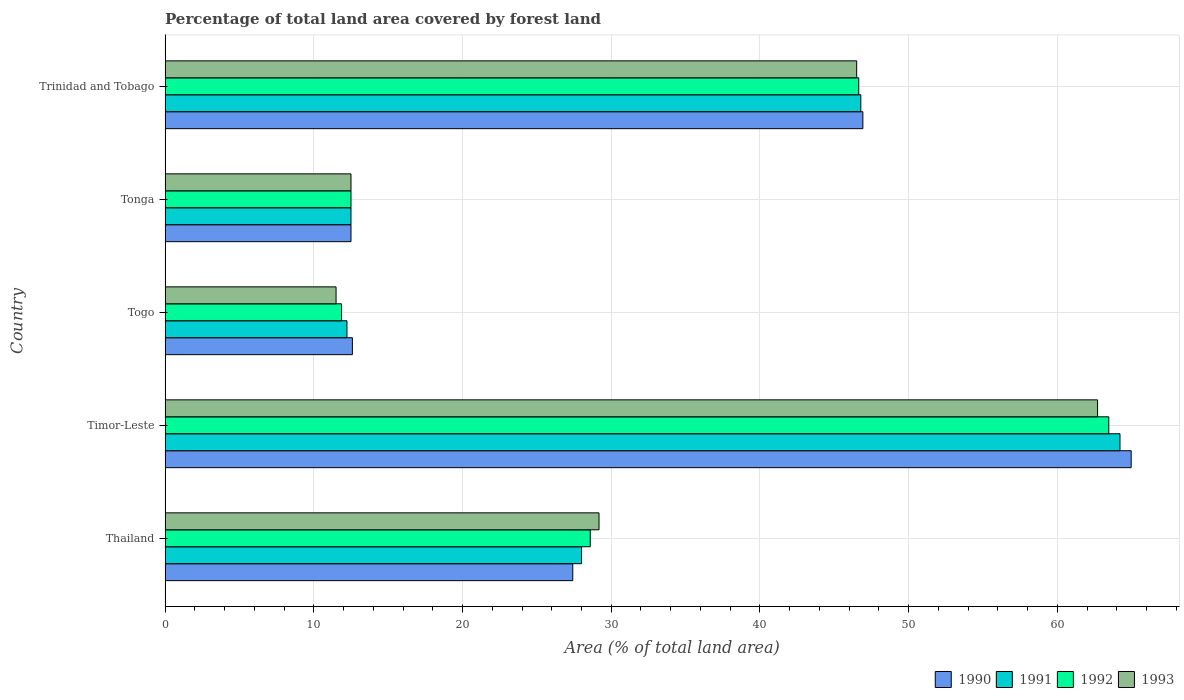How many groups of bars are there?
Your answer should be very brief. 5. Are the number of bars per tick equal to the number of legend labels?
Give a very brief answer. Yes. Are the number of bars on each tick of the Y-axis equal?
Your answer should be compact. Yes. How many bars are there on the 3rd tick from the top?
Provide a succinct answer. 4. What is the label of the 1st group of bars from the top?
Your answer should be very brief. Trinidad and Tobago. In how many cases, is the number of bars for a given country not equal to the number of legend labels?
Your answer should be very brief. 0. Across all countries, what is the maximum percentage of forest land in 1992?
Make the answer very short. 63.46. Across all countries, what is the minimum percentage of forest land in 1992?
Keep it short and to the point. 11.86. In which country was the percentage of forest land in 1992 maximum?
Your answer should be very brief. Timor-Leste. In which country was the percentage of forest land in 1990 minimum?
Make the answer very short. Tonga. What is the total percentage of forest land in 1991 in the graph?
Your answer should be very brief. 163.72. What is the difference between the percentage of forest land in 1990 in Tonga and that in Trinidad and Tobago?
Your answer should be very brief. -34.42. What is the difference between the percentage of forest land in 1990 in Togo and the percentage of forest land in 1991 in Timor-Leste?
Your response must be concise. -51.62. What is the average percentage of forest land in 1991 per country?
Offer a terse response. 32.74. What is the difference between the percentage of forest land in 1993 and percentage of forest land in 1990 in Thailand?
Offer a terse response. 1.77. In how many countries, is the percentage of forest land in 1990 greater than 60 %?
Ensure brevity in your answer.  1. What is the ratio of the percentage of forest land in 1990 in Timor-Leste to that in Trinidad and Tobago?
Offer a very short reply. 1.38. Is the difference between the percentage of forest land in 1993 in Tonga and Trinidad and Tobago greater than the difference between the percentage of forest land in 1990 in Tonga and Trinidad and Tobago?
Your answer should be compact. Yes. What is the difference between the highest and the second highest percentage of forest land in 1992?
Your answer should be compact. 16.81. What is the difference between the highest and the lowest percentage of forest land in 1991?
Provide a short and direct response. 51.98. Is the sum of the percentage of forest land in 1992 in Togo and Trinidad and Tobago greater than the maximum percentage of forest land in 1991 across all countries?
Give a very brief answer. No. Is it the case that in every country, the sum of the percentage of forest land in 1990 and percentage of forest land in 1992 is greater than the sum of percentage of forest land in 1991 and percentage of forest land in 1993?
Offer a terse response. No. What does the 1st bar from the top in Timor-Leste represents?
Your answer should be compact. 1993. How many bars are there?
Your answer should be very brief. 20. Are all the bars in the graph horizontal?
Offer a very short reply. Yes. How many countries are there in the graph?
Your response must be concise. 5. What is the difference between two consecutive major ticks on the X-axis?
Provide a succinct answer. 10. Are the values on the major ticks of X-axis written in scientific E-notation?
Offer a terse response. No. Does the graph contain grids?
Provide a succinct answer. Yes. Where does the legend appear in the graph?
Offer a terse response. Bottom right. What is the title of the graph?
Offer a very short reply. Percentage of total land area covered by forest land. Does "1989" appear as one of the legend labels in the graph?
Your response must be concise. No. What is the label or title of the X-axis?
Provide a succinct answer. Area (% of total land area). What is the Area (% of total land area) of 1990 in Thailand?
Ensure brevity in your answer.  27.41. What is the Area (% of total land area) of 1991 in Thailand?
Make the answer very short. 28. What is the Area (% of total land area) of 1992 in Thailand?
Your response must be concise. 28.59. What is the Area (% of total land area) in 1993 in Thailand?
Offer a terse response. 29.18. What is the Area (% of total land area) of 1990 in Timor-Leste?
Provide a succinct answer. 64.96. What is the Area (% of total land area) of 1991 in Timor-Leste?
Offer a terse response. 64.21. What is the Area (% of total land area) of 1992 in Timor-Leste?
Offer a terse response. 63.46. What is the Area (% of total land area) of 1993 in Timor-Leste?
Provide a short and direct response. 62.7. What is the Area (% of total land area) in 1990 in Togo?
Ensure brevity in your answer.  12.59. What is the Area (% of total land area) in 1991 in Togo?
Offer a very short reply. 12.23. What is the Area (% of total land area) in 1992 in Togo?
Provide a short and direct response. 11.86. What is the Area (% of total land area) of 1993 in Togo?
Offer a very short reply. 11.5. What is the Area (% of total land area) of 1992 in Tonga?
Offer a very short reply. 12.5. What is the Area (% of total land area) of 1993 in Tonga?
Ensure brevity in your answer.  12.5. What is the Area (% of total land area) of 1990 in Trinidad and Tobago?
Make the answer very short. 46.92. What is the Area (% of total land area) in 1991 in Trinidad and Tobago?
Keep it short and to the point. 46.78. What is the Area (% of total land area) of 1992 in Trinidad and Tobago?
Offer a very short reply. 46.64. What is the Area (% of total land area) in 1993 in Trinidad and Tobago?
Provide a short and direct response. 46.5. Across all countries, what is the maximum Area (% of total land area) in 1990?
Your answer should be very brief. 64.96. Across all countries, what is the maximum Area (% of total land area) of 1991?
Give a very brief answer. 64.21. Across all countries, what is the maximum Area (% of total land area) of 1992?
Offer a terse response. 63.46. Across all countries, what is the maximum Area (% of total land area) of 1993?
Your response must be concise. 62.7. Across all countries, what is the minimum Area (% of total land area) of 1991?
Your answer should be very brief. 12.23. Across all countries, what is the minimum Area (% of total land area) in 1992?
Make the answer very short. 11.86. Across all countries, what is the minimum Area (% of total land area) in 1993?
Offer a very short reply. 11.5. What is the total Area (% of total land area) in 1990 in the graph?
Offer a terse response. 164.39. What is the total Area (% of total land area) in 1991 in the graph?
Your answer should be compact. 163.72. What is the total Area (% of total land area) in 1992 in the graph?
Your answer should be very brief. 163.05. What is the total Area (% of total land area) of 1993 in the graph?
Provide a short and direct response. 162.38. What is the difference between the Area (% of total land area) in 1990 in Thailand and that in Timor-Leste?
Your answer should be compact. -37.55. What is the difference between the Area (% of total land area) in 1991 in Thailand and that in Timor-Leste?
Your response must be concise. -36.21. What is the difference between the Area (% of total land area) in 1992 in Thailand and that in Timor-Leste?
Keep it short and to the point. -34.87. What is the difference between the Area (% of total land area) in 1993 in Thailand and that in Timor-Leste?
Offer a terse response. -33.53. What is the difference between the Area (% of total land area) in 1990 in Thailand and that in Togo?
Offer a terse response. 14.82. What is the difference between the Area (% of total land area) in 1991 in Thailand and that in Togo?
Offer a terse response. 15.77. What is the difference between the Area (% of total land area) in 1992 in Thailand and that in Togo?
Make the answer very short. 16.73. What is the difference between the Area (% of total land area) of 1993 in Thailand and that in Togo?
Offer a very short reply. 17.68. What is the difference between the Area (% of total land area) of 1990 in Thailand and that in Tonga?
Keep it short and to the point. 14.91. What is the difference between the Area (% of total land area) of 1991 in Thailand and that in Tonga?
Ensure brevity in your answer.  15.5. What is the difference between the Area (% of total land area) of 1992 in Thailand and that in Tonga?
Give a very brief answer. 16.09. What is the difference between the Area (% of total land area) in 1993 in Thailand and that in Tonga?
Offer a terse response. 16.68. What is the difference between the Area (% of total land area) in 1990 in Thailand and that in Trinidad and Tobago?
Offer a very short reply. -19.51. What is the difference between the Area (% of total land area) of 1991 in Thailand and that in Trinidad and Tobago?
Provide a short and direct response. -18.78. What is the difference between the Area (% of total land area) of 1992 in Thailand and that in Trinidad and Tobago?
Your answer should be compact. -18.05. What is the difference between the Area (% of total land area) of 1993 in Thailand and that in Trinidad and Tobago?
Ensure brevity in your answer.  -17.33. What is the difference between the Area (% of total land area) in 1990 in Timor-Leste and that in Togo?
Offer a terse response. 52.37. What is the difference between the Area (% of total land area) of 1991 in Timor-Leste and that in Togo?
Give a very brief answer. 51.98. What is the difference between the Area (% of total land area) of 1992 in Timor-Leste and that in Togo?
Provide a short and direct response. 51.59. What is the difference between the Area (% of total land area) of 1993 in Timor-Leste and that in Togo?
Provide a short and direct response. 51.21. What is the difference between the Area (% of total land area) in 1990 in Timor-Leste and that in Tonga?
Your response must be concise. 52.46. What is the difference between the Area (% of total land area) of 1991 in Timor-Leste and that in Tonga?
Your answer should be very brief. 51.71. What is the difference between the Area (% of total land area) in 1992 in Timor-Leste and that in Tonga?
Offer a terse response. 50.96. What is the difference between the Area (% of total land area) in 1993 in Timor-Leste and that in Tonga?
Give a very brief answer. 50.2. What is the difference between the Area (% of total land area) in 1990 in Timor-Leste and that in Trinidad and Tobago?
Your answer should be compact. 18.04. What is the difference between the Area (% of total land area) of 1991 in Timor-Leste and that in Trinidad and Tobago?
Make the answer very short. 17.43. What is the difference between the Area (% of total land area) in 1992 in Timor-Leste and that in Trinidad and Tobago?
Give a very brief answer. 16.81. What is the difference between the Area (% of total land area) of 1993 in Timor-Leste and that in Trinidad and Tobago?
Provide a succinct answer. 16.2. What is the difference between the Area (% of total land area) of 1990 in Togo and that in Tonga?
Keep it short and to the point. 0.09. What is the difference between the Area (% of total land area) in 1991 in Togo and that in Tonga?
Your answer should be very brief. -0.27. What is the difference between the Area (% of total land area) in 1992 in Togo and that in Tonga?
Your answer should be very brief. -0.64. What is the difference between the Area (% of total land area) in 1993 in Togo and that in Tonga?
Ensure brevity in your answer.  -1. What is the difference between the Area (% of total land area) in 1990 in Togo and that in Trinidad and Tobago?
Your answer should be very brief. -34.33. What is the difference between the Area (% of total land area) in 1991 in Togo and that in Trinidad and Tobago?
Offer a terse response. -34.55. What is the difference between the Area (% of total land area) in 1992 in Togo and that in Trinidad and Tobago?
Keep it short and to the point. -34.78. What is the difference between the Area (% of total land area) in 1993 in Togo and that in Trinidad and Tobago?
Your response must be concise. -35.01. What is the difference between the Area (% of total land area) of 1990 in Tonga and that in Trinidad and Tobago?
Provide a short and direct response. -34.42. What is the difference between the Area (% of total land area) of 1991 in Tonga and that in Trinidad and Tobago?
Offer a very short reply. -34.28. What is the difference between the Area (% of total land area) in 1992 in Tonga and that in Trinidad and Tobago?
Your answer should be compact. -34.14. What is the difference between the Area (% of total land area) of 1993 in Tonga and that in Trinidad and Tobago?
Your answer should be very brief. -34. What is the difference between the Area (% of total land area) in 1990 in Thailand and the Area (% of total land area) in 1991 in Timor-Leste?
Keep it short and to the point. -36.8. What is the difference between the Area (% of total land area) of 1990 in Thailand and the Area (% of total land area) of 1992 in Timor-Leste?
Offer a very short reply. -36.04. What is the difference between the Area (% of total land area) of 1990 in Thailand and the Area (% of total land area) of 1993 in Timor-Leste?
Give a very brief answer. -35.29. What is the difference between the Area (% of total land area) of 1991 in Thailand and the Area (% of total land area) of 1992 in Timor-Leste?
Offer a terse response. -35.46. What is the difference between the Area (% of total land area) in 1991 in Thailand and the Area (% of total land area) in 1993 in Timor-Leste?
Your answer should be compact. -34.7. What is the difference between the Area (% of total land area) of 1992 in Thailand and the Area (% of total land area) of 1993 in Timor-Leste?
Your response must be concise. -34.11. What is the difference between the Area (% of total land area) of 1990 in Thailand and the Area (% of total land area) of 1991 in Togo?
Your answer should be very brief. 15.18. What is the difference between the Area (% of total land area) of 1990 in Thailand and the Area (% of total land area) of 1992 in Togo?
Offer a very short reply. 15.55. What is the difference between the Area (% of total land area) in 1990 in Thailand and the Area (% of total land area) in 1993 in Togo?
Make the answer very short. 15.92. What is the difference between the Area (% of total land area) in 1991 in Thailand and the Area (% of total land area) in 1992 in Togo?
Offer a very short reply. 16.14. What is the difference between the Area (% of total land area) of 1991 in Thailand and the Area (% of total land area) of 1993 in Togo?
Offer a terse response. 16.5. What is the difference between the Area (% of total land area) of 1992 in Thailand and the Area (% of total land area) of 1993 in Togo?
Make the answer very short. 17.09. What is the difference between the Area (% of total land area) of 1990 in Thailand and the Area (% of total land area) of 1991 in Tonga?
Ensure brevity in your answer.  14.91. What is the difference between the Area (% of total land area) of 1990 in Thailand and the Area (% of total land area) of 1992 in Tonga?
Provide a succinct answer. 14.91. What is the difference between the Area (% of total land area) in 1990 in Thailand and the Area (% of total land area) in 1993 in Tonga?
Offer a very short reply. 14.91. What is the difference between the Area (% of total land area) of 1991 in Thailand and the Area (% of total land area) of 1992 in Tonga?
Ensure brevity in your answer.  15.5. What is the difference between the Area (% of total land area) in 1991 in Thailand and the Area (% of total land area) in 1993 in Tonga?
Provide a short and direct response. 15.5. What is the difference between the Area (% of total land area) in 1992 in Thailand and the Area (% of total land area) in 1993 in Tonga?
Keep it short and to the point. 16.09. What is the difference between the Area (% of total land area) in 1990 in Thailand and the Area (% of total land area) in 1991 in Trinidad and Tobago?
Make the answer very short. -19.37. What is the difference between the Area (% of total land area) in 1990 in Thailand and the Area (% of total land area) in 1992 in Trinidad and Tobago?
Make the answer very short. -19.23. What is the difference between the Area (% of total land area) in 1990 in Thailand and the Area (% of total land area) in 1993 in Trinidad and Tobago?
Offer a terse response. -19.09. What is the difference between the Area (% of total land area) of 1991 in Thailand and the Area (% of total land area) of 1992 in Trinidad and Tobago?
Your answer should be compact. -18.64. What is the difference between the Area (% of total land area) of 1991 in Thailand and the Area (% of total land area) of 1993 in Trinidad and Tobago?
Your answer should be very brief. -18.5. What is the difference between the Area (% of total land area) in 1992 in Thailand and the Area (% of total land area) in 1993 in Trinidad and Tobago?
Your answer should be very brief. -17.92. What is the difference between the Area (% of total land area) in 1990 in Timor-Leste and the Area (% of total land area) in 1991 in Togo?
Your response must be concise. 52.73. What is the difference between the Area (% of total land area) in 1990 in Timor-Leste and the Area (% of total land area) in 1992 in Togo?
Offer a terse response. 53.1. What is the difference between the Area (% of total land area) of 1990 in Timor-Leste and the Area (% of total land area) of 1993 in Togo?
Your answer should be very brief. 53.47. What is the difference between the Area (% of total land area) of 1991 in Timor-Leste and the Area (% of total land area) of 1992 in Togo?
Keep it short and to the point. 52.35. What is the difference between the Area (% of total land area) in 1991 in Timor-Leste and the Area (% of total land area) in 1993 in Togo?
Your answer should be compact. 52.71. What is the difference between the Area (% of total land area) in 1992 in Timor-Leste and the Area (% of total land area) in 1993 in Togo?
Your response must be concise. 51.96. What is the difference between the Area (% of total land area) of 1990 in Timor-Leste and the Area (% of total land area) of 1991 in Tonga?
Offer a very short reply. 52.46. What is the difference between the Area (% of total land area) in 1990 in Timor-Leste and the Area (% of total land area) in 1992 in Tonga?
Give a very brief answer. 52.46. What is the difference between the Area (% of total land area) in 1990 in Timor-Leste and the Area (% of total land area) in 1993 in Tonga?
Provide a succinct answer. 52.46. What is the difference between the Area (% of total land area) of 1991 in Timor-Leste and the Area (% of total land area) of 1992 in Tonga?
Your answer should be very brief. 51.71. What is the difference between the Area (% of total land area) in 1991 in Timor-Leste and the Area (% of total land area) in 1993 in Tonga?
Your answer should be compact. 51.71. What is the difference between the Area (% of total land area) in 1992 in Timor-Leste and the Area (% of total land area) in 1993 in Tonga?
Ensure brevity in your answer.  50.96. What is the difference between the Area (% of total land area) of 1990 in Timor-Leste and the Area (% of total land area) of 1991 in Trinidad and Tobago?
Provide a short and direct response. 18.18. What is the difference between the Area (% of total land area) of 1990 in Timor-Leste and the Area (% of total land area) of 1992 in Trinidad and Tobago?
Give a very brief answer. 18.32. What is the difference between the Area (% of total land area) in 1990 in Timor-Leste and the Area (% of total land area) in 1993 in Trinidad and Tobago?
Your answer should be compact. 18.46. What is the difference between the Area (% of total land area) in 1991 in Timor-Leste and the Area (% of total land area) in 1992 in Trinidad and Tobago?
Give a very brief answer. 17.57. What is the difference between the Area (% of total land area) in 1991 in Timor-Leste and the Area (% of total land area) in 1993 in Trinidad and Tobago?
Provide a short and direct response. 17.7. What is the difference between the Area (% of total land area) in 1992 in Timor-Leste and the Area (% of total land area) in 1993 in Trinidad and Tobago?
Provide a succinct answer. 16.95. What is the difference between the Area (% of total land area) in 1990 in Togo and the Area (% of total land area) in 1991 in Tonga?
Offer a very short reply. 0.09. What is the difference between the Area (% of total land area) of 1990 in Togo and the Area (% of total land area) of 1992 in Tonga?
Provide a succinct answer. 0.09. What is the difference between the Area (% of total land area) in 1990 in Togo and the Area (% of total land area) in 1993 in Tonga?
Offer a terse response. 0.09. What is the difference between the Area (% of total land area) of 1991 in Togo and the Area (% of total land area) of 1992 in Tonga?
Offer a terse response. -0.27. What is the difference between the Area (% of total land area) of 1991 in Togo and the Area (% of total land area) of 1993 in Tonga?
Keep it short and to the point. -0.27. What is the difference between the Area (% of total land area) of 1992 in Togo and the Area (% of total land area) of 1993 in Tonga?
Offer a very short reply. -0.64. What is the difference between the Area (% of total land area) of 1990 in Togo and the Area (% of total land area) of 1991 in Trinidad and Tobago?
Provide a succinct answer. -34.19. What is the difference between the Area (% of total land area) in 1990 in Togo and the Area (% of total land area) in 1992 in Trinidad and Tobago?
Give a very brief answer. -34.05. What is the difference between the Area (% of total land area) in 1990 in Togo and the Area (% of total land area) in 1993 in Trinidad and Tobago?
Provide a short and direct response. -33.91. What is the difference between the Area (% of total land area) of 1991 in Togo and the Area (% of total land area) of 1992 in Trinidad and Tobago?
Provide a succinct answer. -34.41. What is the difference between the Area (% of total land area) in 1991 in Togo and the Area (% of total land area) in 1993 in Trinidad and Tobago?
Provide a succinct answer. -34.28. What is the difference between the Area (% of total land area) of 1992 in Togo and the Area (% of total land area) of 1993 in Trinidad and Tobago?
Offer a very short reply. -34.64. What is the difference between the Area (% of total land area) in 1990 in Tonga and the Area (% of total land area) in 1991 in Trinidad and Tobago?
Offer a very short reply. -34.28. What is the difference between the Area (% of total land area) of 1990 in Tonga and the Area (% of total land area) of 1992 in Trinidad and Tobago?
Provide a succinct answer. -34.14. What is the difference between the Area (% of total land area) in 1990 in Tonga and the Area (% of total land area) in 1993 in Trinidad and Tobago?
Offer a terse response. -34. What is the difference between the Area (% of total land area) of 1991 in Tonga and the Area (% of total land area) of 1992 in Trinidad and Tobago?
Keep it short and to the point. -34.14. What is the difference between the Area (% of total land area) of 1991 in Tonga and the Area (% of total land area) of 1993 in Trinidad and Tobago?
Offer a very short reply. -34. What is the difference between the Area (% of total land area) in 1992 in Tonga and the Area (% of total land area) in 1993 in Trinidad and Tobago?
Keep it short and to the point. -34. What is the average Area (% of total land area) in 1990 per country?
Offer a terse response. 32.88. What is the average Area (% of total land area) of 1991 per country?
Make the answer very short. 32.74. What is the average Area (% of total land area) in 1992 per country?
Offer a terse response. 32.61. What is the average Area (% of total land area) in 1993 per country?
Your response must be concise. 32.48. What is the difference between the Area (% of total land area) of 1990 and Area (% of total land area) of 1991 in Thailand?
Provide a short and direct response. -0.59. What is the difference between the Area (% of total land area) in 1990 and Area (% of total land area) in 1992 in Thailand?
Provide a succinct answer. -1.18. What is the difference between the Area (% of total land area) of 1990 and Area (% of total land area) of 1993 in Thailand?
Offer a very short reply. -1.77. What is the difference between the Area (% of total land area) of 1991 and Area (% of total land area) of 1992 in Thailand?
Ensure brevity in your answer.  -0.59. What is the difference between the Area (% of total land area) in 1991 and Area (% of total land area) in 1993 in Thailand?
Give a very brief answer. -1.18. What is the difference between the Area (% of total land area) in 1992 and Area (% of total land area) in 1993 in Thailand?
Provide a short and direct response. -0.59. What is the difference between the Area (% of total land area) in 1990 and Area (% of total land area) in 1991 in Timor-Leste?
Provide a succinct answer. 0.75. What is the difference between the Area (% of total land area) in 1990 and Area (% of total land area) in 1992 in Timor-Leste?
Your answer should be compact. 1.51. What is the difference between the Area (% of total land area) in 1990 and Area (% of total land area) in 1993 in Timor-Leste?
Offer a very short reply. 2.26. What is the difference between the Area (% of total land area) of 1991 and Area (% of total land area) of 1992 in Timor-Leste?
Offer a terse response. 0.75. What is the difference between the Area (% of total land area) of 1991 and Area (% of total land area) of 1993 in Timor-Leste?
Keep it short and to the point. 1.51. What is the difference between the Area (% of total land area) of 1992 and Area (% of total land area) of 1993 in Timor-Leste?
Your answer should be compact. 0.75. What is the difference between the Area (% of total land area) in 1990 and Area (% of total land area) in 1991 in Togo?
Provide a succinct answer. 0.37. What is the difference between the Area (% of total land area) in 1990 and Area (% of total land area) in 1992 in Togo?
Provide a succinct answer. 0.73. What is the difference between the Area (% of total land area) of 1990 and Area (% of total land area) of 1993 in Togo?
Your answer should be compact. 1.1. What is the difference between the Area (% of total land area) of 1991 and Area (% of total land area) of 1992 in Togo?
Offer a very short reply. 0.37. What is the difference between the Area (% of total land area) in 1991 and Area (% of total land area) in 1993 in Togo?
Your answer should be very brief. 0.73. What is the difference between the Area (% of total land area) in 1992 and Area (% of total land area) in 1993 in Togo?
Offer a terse response. 0.37. What is the difference between the Area (% of total land area) in 1990 and Area (% of total land area) in 1991 in Tonga?
Make the answer very short. 0. What is the difference between the Area (% of total land area) of 1991 and Area (% of total land area) of 1993 in Tonga?
Offer a terse response. 0. What is the difference between the Area (% of total land area) in 1992 and Area (% of total land area) in 1993 in Tonga?
Offer a terse response. 0. What is the difference between the Area (% of total land area) of 1990 and Area (% of total land area) of 1991 in Trinidad and Tobago?
Your response must be concise. 0.14. What is the difference between the Area (% of total land area) in 1990 and Area (% of total land area) in 1992 in Trinidad and Tobago?
Provide a succinct answer. 0.28. What is the difference between the Area (% of total land area) of 1990 and Area (% of total land area) of 1993 in Trinidad and Tobago?
Ensure brevity in your answer.  0.42. What is the difference between the Area (% of total land area) of 1991 and Area (% of total land area) of 1992 in Trinidad and Tobago?
Keep it short and to the point. 0.14. What is the difference between the Area (% of total land area) of 1991 and Area (% of total land area) of 1993 in Trinidad and Tobago?
Give a very brief answer. 0.28. What is the difference between the Area (% of total land area) in 1992 and Area (% of total land area) in 1993 in Trinidad and Tobago?
Your answer should be compact. 0.14. What is the ratio of the Area (% of total land area) of 1990 in Thailand to that in Timor-Leste?
Offer a very short reply. 0.42. What is the ratio of the Area (% of total land area) of 1991 in Thailand to that in Timor-Leste?
Your answer should be very brief. 0.44. What is the ratio of the Area (% of total land area) of 1992 in Thailand to that in Timor-Leste?
Give a very brief answer. 0.45. What is the ratio of the Area (% of total land area) in 1993 in Thailand to that in Timor-Leste?
Your response must be concise. 0.47. What is the ratio of the Area (% of total land area) in 1990 in Thailand to that in Togo?
Keep it short and to the point. 2.18. What is the ratio of the Area (% of total land area) in 1991 in Thailand to that in Togo?
Make the answer very short. 2.29. What is the ratio of the Area (% of total land area) in 1992 in Thailand to that in Togo?
Ensure brevity in your answer.  2.41. What is the ratio of the Area (% of total land area) in 1993 in Thailand to that in Togo?
Your response must be concise. 2.54. What is the ratio of the Area (% of total land area) in 1990 in Thailand to that in Tonga?
Keep it short and to the point. 2.19. What is the ratio of the Area (% of total land area) of 1991 in Thailand to that in Tonga?
Your answer should be compact. 2.24. What is the ratio of the Area (% of total land area) of 1992 in Thailand to that in Tonga?
Offer a very short reply. 2.29. What is the ratio of the Area (% of total land area) in 1993 in Thailand to that in Tonga?
Your answer should be very brief. 2.33. What is the ratio of the Area (% of total land area) in 1990 in Thailand to that in Trinidad and Tobago?
Ensure brevity in your answer.  0.58. What is the ratio of the Area (% of total land area) in 1991 in Thailand to that in Trinidad and Tobago?
Ensure brevity in your answer.  0.6. What is the ratio of the Area (% of total land area) in 1992 in Thailand to that in Trinidad and Tobago?
Offer a very short reply. 0.61. What is the ratio of the Area (% of total land area) in 1993 in Thailand to that in Trinidad and Tobago?
Your response must be concise. 0.63. What is the ratio of the Area (% of total land area) in 1990 in Timor-Leste to that in Togo?
Provide a succinct answer. 5.16. What is the ratio of the Area (% of total land area) of 1991 in Timor-Leste to that in Togo?
Make the answer very short. 5.25. What is the ratio of the Area (% of total land area) of 1992 in Timor-Leste to that in Togo?
Provide a short and direct response. 5.35. What is the ratio of the Area (% of total land area) of 1993 in Timor-Leste to that in Togo?
Give a very brief answer. 5.45. What is the ratio of the Area (% of total land area) in 1990 in Timor-Leste to that in Tonga?
Provide a short and direct response. 5.2. What is the ratio of the Area (% of total land area) in 1991 in Timor-Leste to that in Tonga?
Provide a short and direct response. 5.14. What is the ratio of the Area (% of total land area) in 1992 in Timor-Leste to that in Tonga?
Provide a short and direct response. 5.08. What is the ratio of the Area (% of total land area) of 1993 in Timor-Leste to that in Tonga?
Ensure brevity in your answer.  5.02. What is the ratio of the Area (% of total land area) in 1990 in Timor-Leste to that in Trinidad and Tobago?
Keep it short and to the point. 1.38. What is the ratio of the Area (% of total land area) in 1991 in Timor-Leste to that in Trinidad and Tobago?
Your answer should be compact. 1.37. What is the ratio of the Area (% of total land area) of 1992 in Timor-Leste to that in Trinidad and Tobago?
Give a very brief answer. 1.36. What is the ratio of the Area (% of total land area) in 1993 in Timor-Leste to that in Trinidad and Tobago?
Give a very brief answer. 1.35. What is the ratio of the Area (% of total land area) of 1990 in Togo to that in Tonga?
Your answer should be very brief. 1.01. What is the ratio of the Area (% of total land area) in 1991 in Togo to that in Tonga?
Give a very brief answer. 0.98. What is the ratio of the Area (% of total land area) of 1992 in Togo to that in Tonga?
Your answer should be very brief. 0.95. What is the ratio of the Area (% of total land area) of 1993 in Togo to that in Tonga?
Make the answer very short. 0.92. What is the ratio of the Area (% of total land area) in 1990 in Togo to that in Trinidad and Tobago?
Offer a very short reply. 0.27. What is the ratio of the Area (% of total land area) in 1991 in Togo to that in Trinidad and Tobago?
Your answer should be compact. 0.26. What is the ratio of the Area (% of total land area) in 1992 in Togo to that in Trinidad and Tobago?
Give a very brief answer. 0.25. What is the ratio of the Area (% of total land area) in 1993 in Togo to that in Trinidad and Tobago?
Offer a terse response. 0.25. What is the ratio of the Area (% of total land area) of 1990 in Tonga to that in Trinidad and Tobago?
Your answer should be very brief. 0.27. What is the ratio of the Area (% of total land area) of 1991 in Tonga to that in Trinidad and Tobago?
Offer a terse response. 0.27. What is the ratio of the Area (% of total land area) of 1992 in Tonga to that in Trinidad and Tobago?
Your answer should be compact. 0.27. What is the ratio of the Area (% of total land area) of 1993 in Tonga to that in Trinidad and Tobago?
Offer a very short reply. 0.27. What is the difference between the highest and the second highest Area (% of total land area) of 1990?
Offer a very short reply. 18.04. What is the difference between the highest and the second highest Area (% of total land area) in 1991?
Offer a terse response. 17.43. What is the difference between the highest and the second highest Area (% of total land area) of 1992?
Your answer should be compact. 16.81. What is the difference between the highest and the second highest Area (% of total land area) in 1993?
Your answer should be compact. 16.2. What is the difference between the highest and the lowest Area (% of total land area) of 1990?
Offer a terse response. 52.46. What is the difference between the highest and the lowest Area (% of total land area) of 1991?
Ensure brevity in your answer.  51.98. What is the difference between the highest and the lowest Area (% of total land area) of 1992?
Your answer should be compact. 51.59. What is the difference between the highest and the lowest Area (% of total land area) in 1993?
Your answer should be very brief. 51.21. 